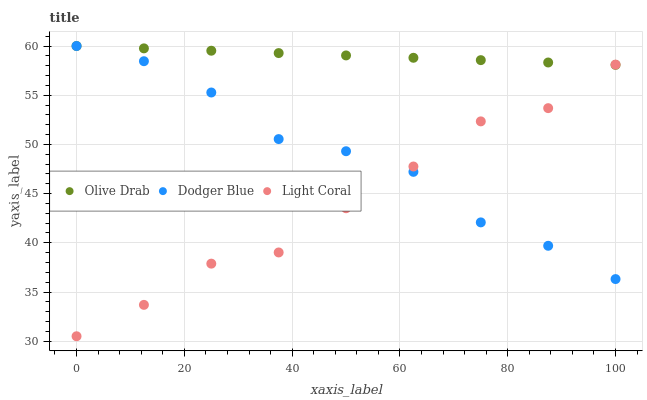Does Light Coral have the minimum area under the curve?
Answer yes or no. Yes. Does Olive Drab have the maximum area under the curve?
Answer yes or no. Yes. Does Dodger Blue have the minimum area under the curve?
Answer yes or no. No. Does Dodger Blue have the maximum area under the curve?
Answer yes or no. No. Is Olive Drab the smoothest?
Answer yes or no. Yes. Is Dodger Blue the roughest?
Answer yes or no. Yes. Is Dodger Blue the smoothest?
Answer yes or no. No. Is Olive Drab the roughest?
Answer yes or no. No. Does Light Coral have the lowest value?
Answer yes or no. Yes. Does Dodger Blue have the lowest value?
Answer yes or no. No. Does Olive Drab have the highest value?
Answer yes or no. Yes. Does Dodger Blue intersect Light Coral?
Answer yes or no. Yes. Is Dodger Blue less than Light Coral?
Answer yes or no. No. Is Dodger Blue greater than Light Coral?
Answer yes or no. No. 